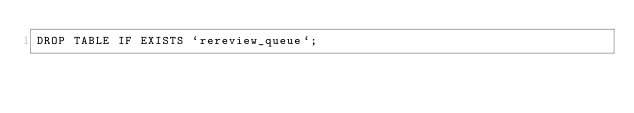Convert code to text. <code><loc_0><loc_0><loc_500><loc_500><_SQL_>DROP TABLE IF EXISTS `rereview_queue`;
</code> 